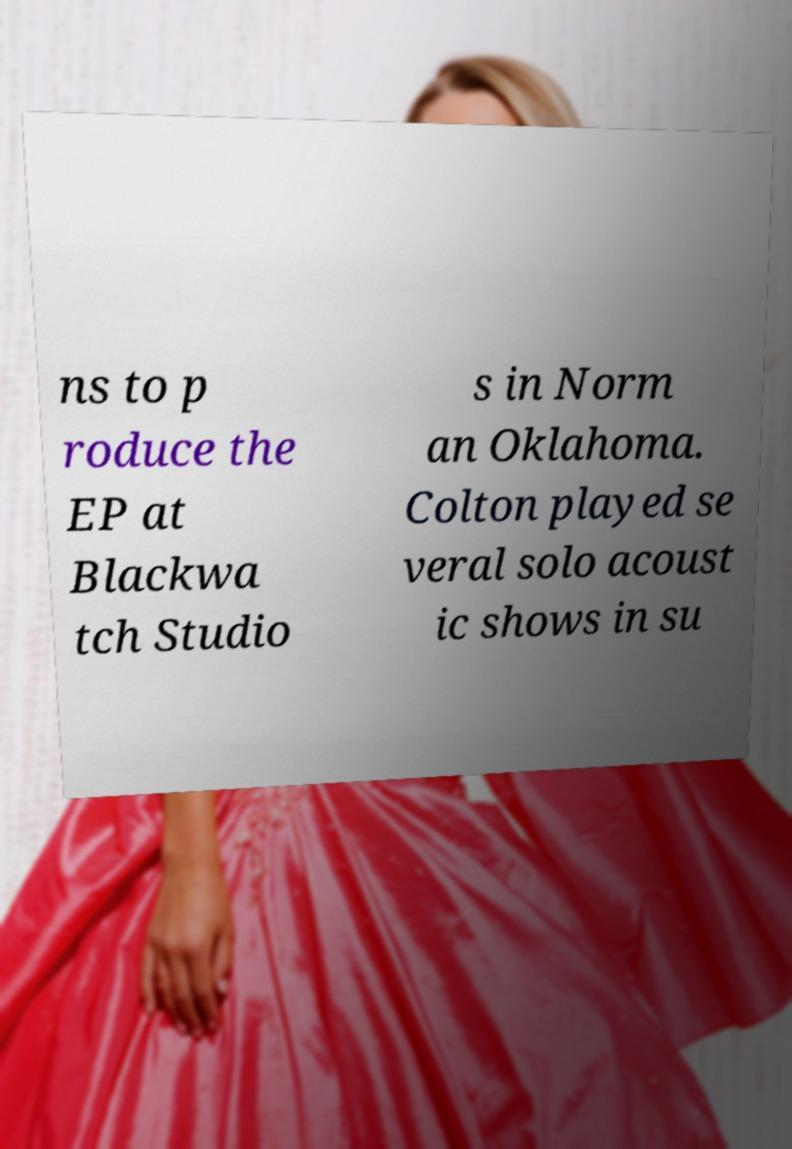Could you assist in decoding the text presented in this image and type it out clearly? ns to p roduce the EP at Blackwa tch Studio s in Norm an Oklahoma. Colton played se veral solo acoust ic shows in su 